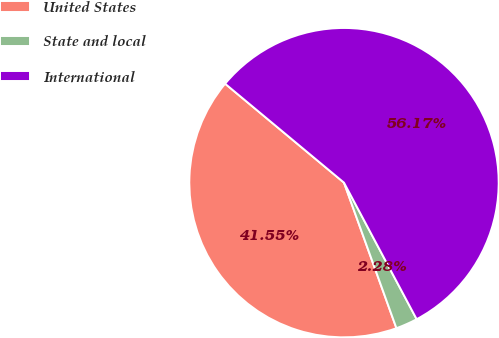Convert chart to OTSL. <chart><loc_0><loc_0><loc_500><loc_500><pie_chart><fcel>United States<fcel>State and local<fcel>International<nl><fcel>41.55%<fcel>2.28%<fcel>56.17%<nl></chart> 